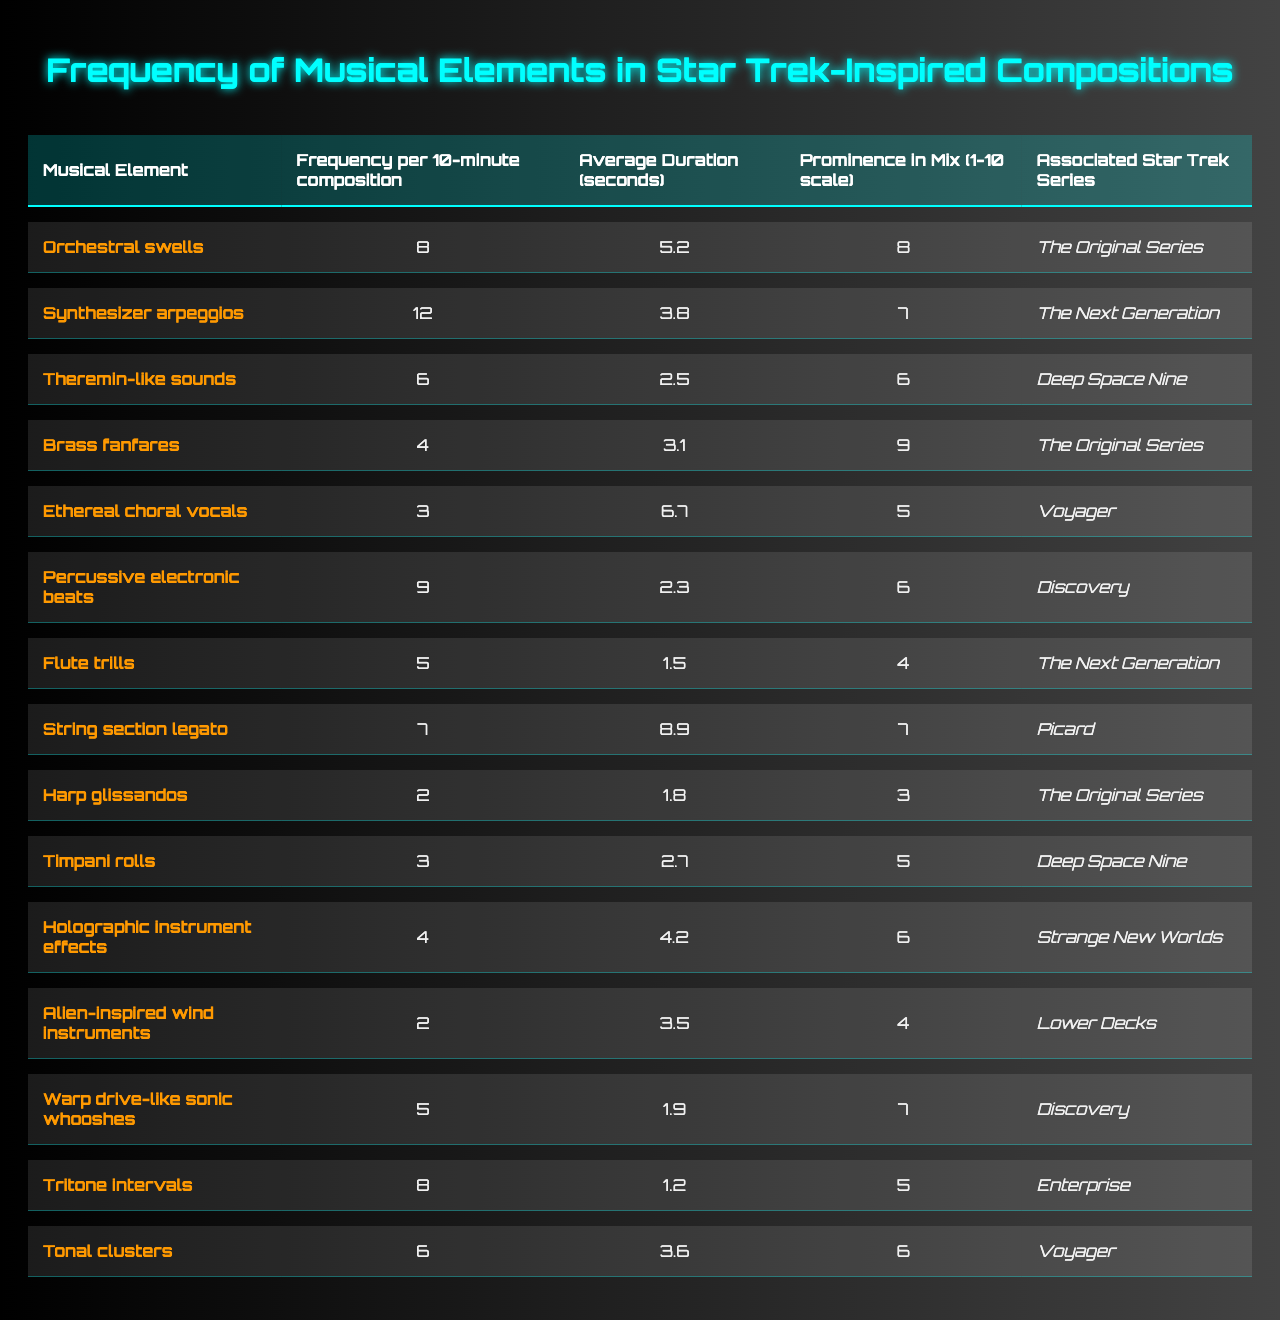What is the frequency of orchestral swells in a 10-minute composition? The table shows that orchestral swells have a frequency of 8.
Answer: 8 Which musical element has the highest prominence in the mix? The highest prominence is 9, which corresponds to brass fanfares.
Answer: Brass fanfares What is the average duration of synthesizer arpeggios? The average duration for synthesizer arpeggios is 3.8 seconds.
Answer: 3.8 seconds How many musical elements have a frequency greater than 6? The elements with frequencies greater than 6 are orchestral swells (8), synthesizer arpeggios (12), percussive electronic beats (9), and warp drive-like sonic whooshes (8) – totaling 4 elements.
Answer: 4 What is the total frequency of all musical elements combined? The sum of the frequencies is 8 + 12 + 6 + 4 + 3 + 9 + 5 + 7 + 2 + 3 + 4 + 2 + 5 + 8 + 6 = 66.
Answer: 66 Is the average duration of harp glissandos greater than 2 seconds? The average duration for harp glissandos is 1.8 seconds, which is not greater than 2 seconds.
Answer: No Which Star Trek series is associated with the most musical elements? The Original Series is associated with 4 elements (orchestral swells, brass fanfares, flute trills, and harp glissandos), which is the highest.
Answer: The Original Series What is the average prominence of musical elements associated with Voyager? The associated elements for Voyager are ethereal choral vocals (5) and tritone intervals (6), so the average is (5 + 6) / 2 = 5.5.
Answer: 5.5 Are percussive electronic beats more prominent in the mix than alien-inspired wind instruments? Percussive electronic beats have a prominence of 6, while alien-inspired wind instruments have a prominence of 4. Since 6 is greater than 4, the answer is yes.
Answer: Yes What is the combined average duration of the musical elements associated with Deep Space Nine? The durations for Deep Space Nine are 3.1 seconds (brass fanfares) and 2.7 seconds (timpani rolls), so the combined average is (3.1 + 2.7) / 2 = 2.9 seconds.
Answer: 2.9 seconds 